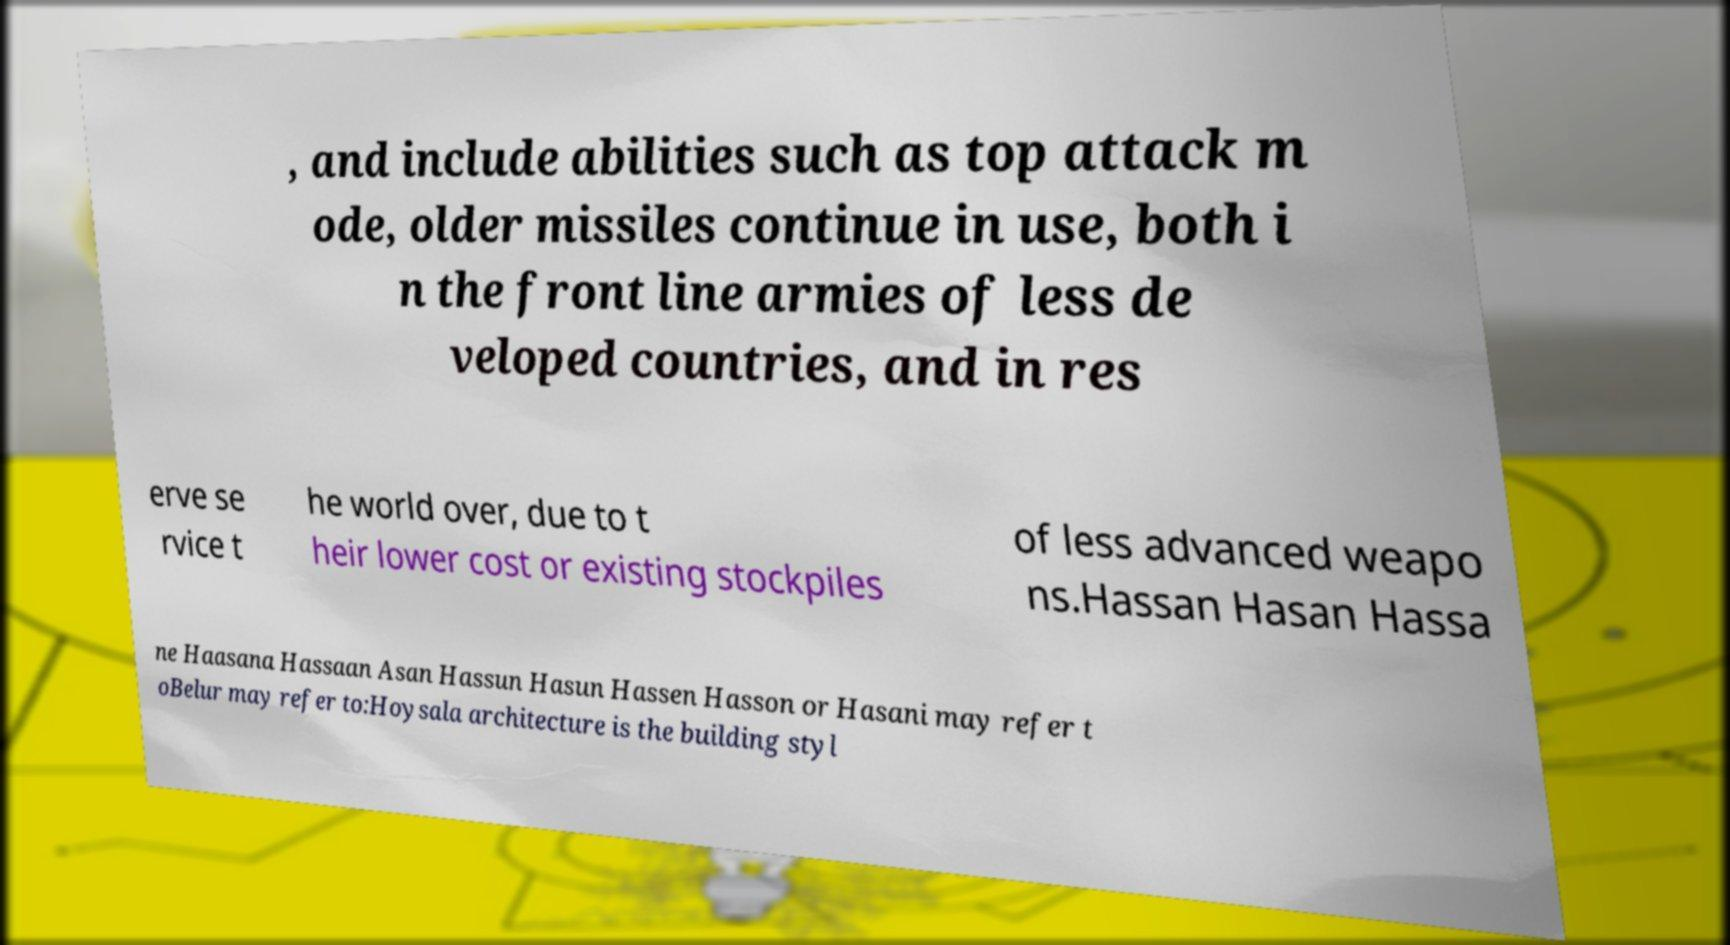Can you accurately transcribe the text from the provided image for me? , and include abilities such as top attack m ode, older missiles continue in use, both i n the front line armies of less de veloped countries, and in res erve se rvice t he world over, due to t heir lower cost or existing stockpiles of less advanced weapo ns.Hassan Hasan Hassa ne Haasana Hassaan Asan Hassun Hasun Hassen Hasson or Hasani may refer t oBelur may refer to:Hoysala architecture is the building styl 